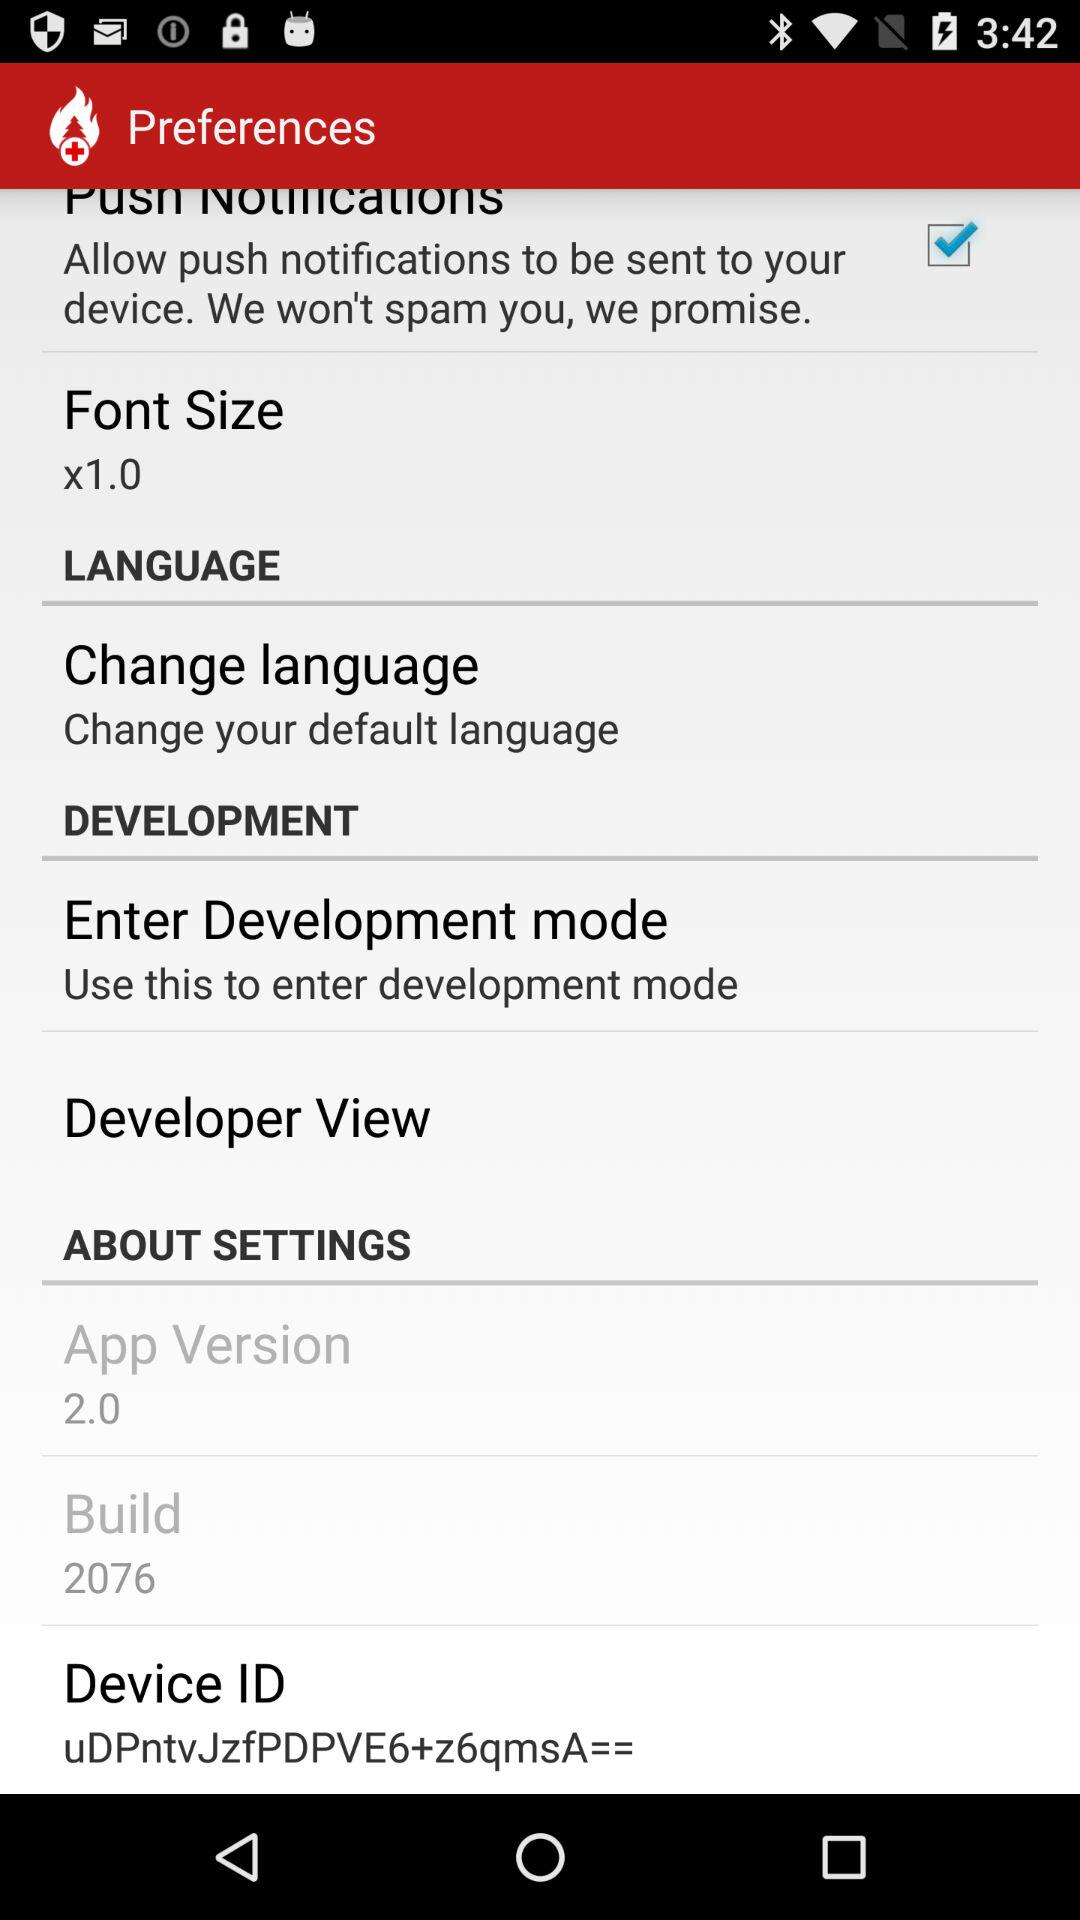What is the build version of the application? The build version is 2076. 